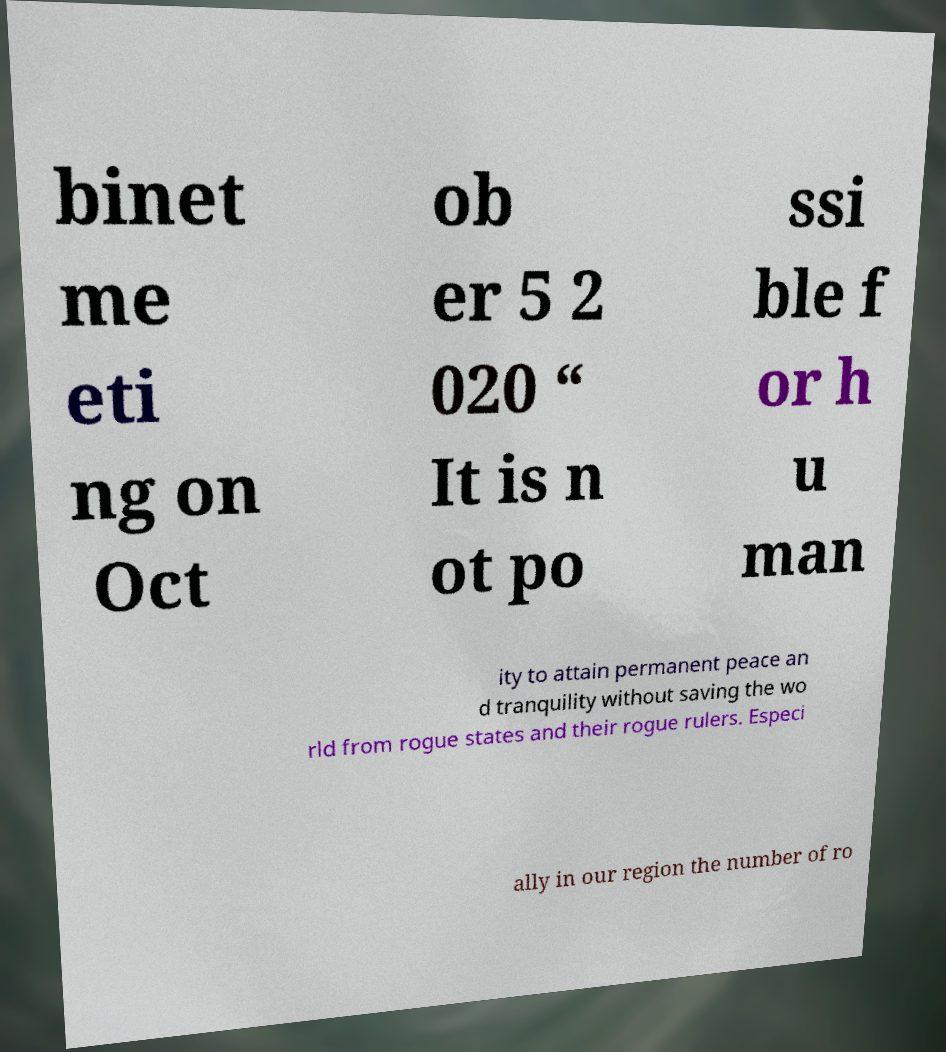Please identify and transcribe the text found in this image. binet me eti ng on Oct ob er 5 2 020 “ It is n ot po ssi ble f or h u man ity to attain permanent peace an d tranquility without saving the wo rld from rogue states and their rogue rulers. Especi ally in our region the number of ro 